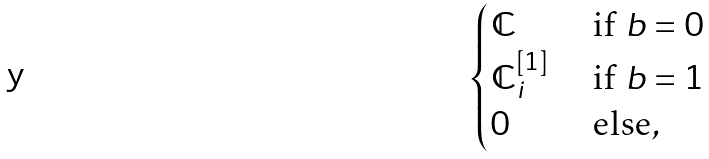Convert formula to latex. <formula><loc_0><loc_0><loc_500><loc_500>\begin{cases} { \mathbb { C } } & \text { if } b = 0 \\ { \mathbb { C } } _ { i } ^ { [ 1 ] } & \text { if } b = 1 \\ 0 & \text { else} , \end{cases}</formula> 